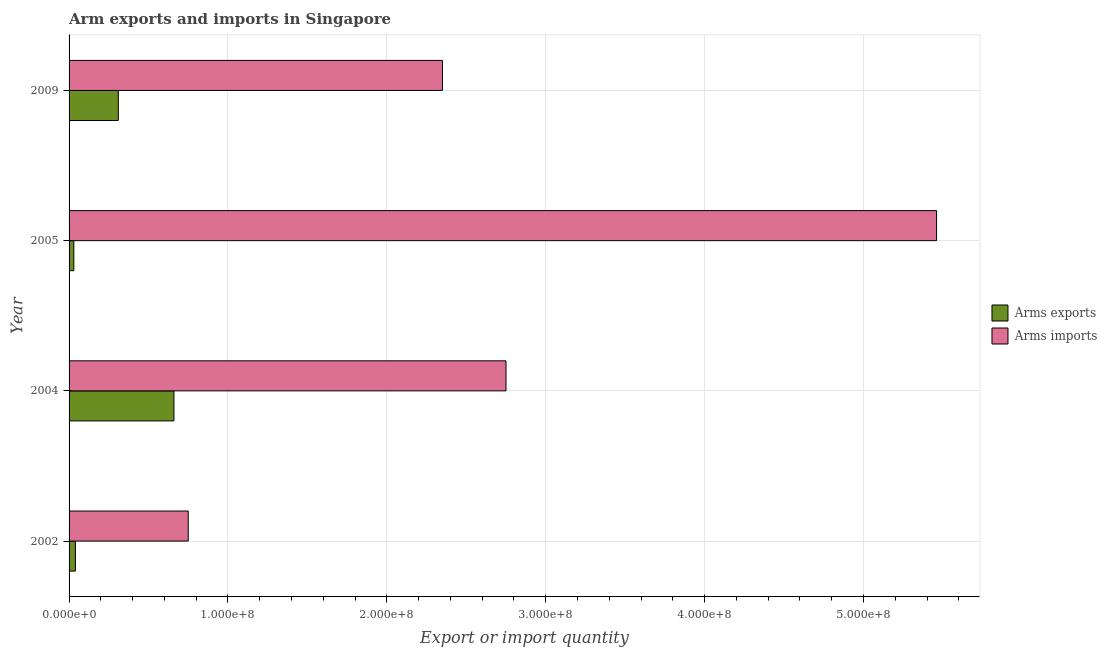Are the number of bars per tick equal to the number of legend labels?
Your response must be concise. Yes. How many bars are there on the 4th tick from the bottom?
Give a very brief answer. 2. In how many cases, is the number of bars for a given year not equal to the number of legend labels?
Provide a succinct answer. 0. What is the arms imports in 2002?
Make the answer very short. 7.50e+07. Across all years, what is the maximum arms exports?
Provide a short and direct response. 6.60e+07. Across all years, what is the minimum arms exports?
Your response must be concise. 3.00e+06. In which year was the arms imports maximum?
Your answer should be compact. 2005. In which year was the arms exports minimum?
Ensure brevity in your answer.  2005. What is the total arms exports in the graph?
Make the answer very short. 1.04e+08. What is the difference between the arms exports in 2002 and that in 2005?
Make the answer very short. 1.00e+06. What is the difference between the arms imports in 2009 and the arms exports in 2005?
Make the answer very short. 2.32e+08. What is the average arms exports per year?
Offer a terse response. 2.60e+07. In the year 2009, what is the difference between the arms imports and arms exports?
Make the answer very short. 2.04e+08. What is the ratio of the arms exports in 2002 to that in 2004?
Offer a terse response. 0.06. Is the arms imports in 2002 less than that in 2004?
Your response must be concise. Yes. Is the difference between the arms imports in 2004 and 2005 greater than the difference between the arms exports in 2004 and 2005?
Ensure brevity in your answer.  No. What is the difference between the highest and the second highest arms imports?
Ensure brevity in your answer.  2.71e+08. What is the difference between the highest and the lowest arms exports?
Provide a succinct answer. 6.30e+07. In how many years, is the arms exports greater than the average arms exports taken over all years?
Keep it short and to the point. 2. What does the 1st bar from the top in 2005 represents?
Your response must be concise. Arms imports. What does the 1st bar from the bottom in 2004 represents?
Your answer should be compact. Arms exports. Are all the bars in the graph horizontal?
Give a very brief answer. Yes. How many years are there in the graph?
Offer a very short reply. 4. What is the difference between two consecutive major ticks on the X-axis?
Ensure brevity in your answer.  1.00e+08. Does the graph contain any zero values?
Make the answer very short. No. How many legend labels are there?
Ensure brevity in your answer.  2. What is the title of the graph?
Keep it short and to the point. Arm exports and imports in Singapore. Does "Mobile cellular" appear as one of the legend labels in the graph?
Offer a terse response. No. What is the label or title of the X-axis?
Offer a terse response. Export or import quantity. What is the Export or import quantity of Arms imports in 2002?
Offer a terse response. 7.50e+07. What is the Export or import quantity in Arms exports in 2004?
Provide a succinct answer. 6.60e+07. What is the Export or import quantity of Arms imports in 2004?
Give a very brief answer. 2.75e+08. What is the Export or import quantity in Arms exports in 2005?
Provide a short and direct response. 3.00e+06. What is the Export or import quantity of Arms imports in 2005?
Your answer should be very brief. 5.46e+08. What is the Export or import quantity of Arms exports in 2009?
Offer a terse response. 3.10e+07. What is the Export or import quantity in Arms imports in 2009?
Keep it short and to the point. 2.35e+08. Across all years, what is the maximum Export or import quantity in Arms exports?
Ensure brevity in your answer.  6.60e+07. Across all years, what is the maximum Export or import quantity in Arms imports?
Your response must be concise. 5.46e+08. Across all years, what is the minimum Export or import quantity of Arms exports?
Your answer should be very brief. 3.00e+06. Across all years, what is the minimum Export or import quantity in Arms imports?
Offer a terse response. 7.50e+07. What is the total Export or import quantity in Arms exports in the graph?
Your answer should be very brief. 1.04e+08. What is the total Export or import quantity of Arms imports in the graph?
Provide a succinct answer. 1.13e+09. What is the difference between the Export or import quantity of Arms exports in 2002 and that in 2004?
Your response must be concise. -6.20e+07. What is the difference between the Export or import quantity in Arms imports in 2002 and that in 2004?
Offer a terse response. -2.00e+08. What is the difference between the Export or import quantity of Arms imports in 2002 and that in 2005?
Keep it short and to the point. -4.71e+08. What is the difference between the Export or import quantity in Arms exports in 2002 and that in 2009?
Offer a terse response. -2.70e+07. What is the difference between the Export or import quantity in Arms imports in 2002 and that in 2009?
Give a very brief answer. -1.60e+08. What is the difference between the Export or import quantity of Arms exports in 2004 and that in 2005?
Ensure brevity in your answer.  6.30e+07. What is the difference between the Export or import quantity of Arms imports in 2004 and that in 2005?
Give a very brief answer. -2.71e+08. What is the difference between the Export or import quantity of Arms exports in 2004 and that in 2009?
Keep it short and to the point. 3.50e+07. What is the difference between the Export or import quantity in Arms imports in 2004 and that in 2009?
Your answer should be very brief. 4.00e+07. What is the difference between the Export or import quantity in Arms exports in 2005 and that in 2009?
Ensure brevity in your answer.  -2.80e+07. What is the difference between the Export or import quantity of Arms imports in 2005 and that in 2009?
Ensure brevity in your answer.  3.11e+08. What is the difference between the Export or import quantity in Arms exports in 2002 and the Export or import quantity in Arms imports in 2004?
Ensure brevity in your answer.  -2.71e+08. What is the difference between the Export or import quantity of Arms exports in 2002 and the Export or import quantity of Arms imports in 2005?
Offer a terse response. -5.42e+08. What is the difference between the Export or import quantity of Arms exports in 2002 and the Export or import quantity of Arms imports in 2009?
Provide a short and direct response. -2.31e+08. What is the difference between the Export or import quantity of Arms exports in 2004 and the Export or import quantity of Arms imports in 2005?
Keep it short and to the point. -4.80e+08. What is the difference between the Export or import quantity in Arms exports in 2004 and the Export or import quantity in Arms imports in 2009?
Provide a succinct answer. -1.69e+08. What is the difference between the Export or import quantity in Arms exports in 2005 and the Export or import quantity in Arms imports in 2009?
Give a very brief answer. -2.32e+08. What is the average Export or import quantity of Arms exports per year?
Your answer should be compact. 2.60e+07. What is the average Export or import quantity of Arms imports per year?
Ensure brevity in your answer.  2.83e+08. In the year 2002, what is the difference between the Export or import quantity of Arms exports and Export or import quantity of Arms imports?
Offer a terse response. -7.10e+07. In the year 2004, what is the difference between the Export or import quantity in Arms exports and Export or import quantity in Arms imports?
Ensure brevity in your answer.  -2.09e+08. In the year 2005, what is the difference between the Export or import quantity in Arms exports and Export or import quantity in Arms imports?
Keep it short and to the point. -5.43e+08. In the year 2009, what is the difference between the Export or import quantity of Arms exports and Export or import quantity of Arms imports?
Your answer should be very brief. -2.04e+08. What is the ratio of the Export or import quantity in Arms exports in 2002 to that in 2004?
Make the answer very short. 0.06. What is the ratio of the Export or import quantity in Arms imports in 2002 to that in 2004?
Give a very brief answer. 0.27. What is the ratio of the Export or import quantity of Arms exports in 2002 to that in 2005?
Make the answer very short. 1.33. What is the ratio of the Export or import quantity of Arms imports in 2002 to that in 2005?
Offer a terse response. 0.14. What is the ratio of the Export or import quantity in Arms exports in 2002 to that in 2009?
Your answer should be compact. 0.13. What is the ratio of the Export or import quantity of Arms imports in 2002 to that in 2009?
Keep it short and to the point. 0.32. What is the ratio of the Export or import quantity in Arms imports in 2004 to that in 2005?
Your response must be concise. 0.5. What is the ratio of the Export or import quantity of Arms exports in 2004 to that in 2009?
Offer a terse response. 2.13. What is the ratio of the Export or import quantity in Arms imports in 2004 to that in 2009?
Your answer should be compact. 1.17. What is the ratio of the Export or import quantity of Arms exports in 2005 to that in 2009?
Make the answer very short. 0.1. What is the ratio of the Export or import quantity of Arms imports in 2005 to that in 2009?
Keep it short and to the point. 2.32. What is the difference between the highest and the second highest Export or import quantity of Arms exports?
Your response must be concise. 3.50e+07. What is the difference between the highest and the second highest Export or import quantity of Arms imports?
Your answer should be compact. 2.71e+08. What is the difference between the highest and the lowest Export or import quantity of Arms exports?
Provide a short and direct response. 6.30e+07. What is the difference between the highest and the lowest Export or import quantity in Arms imports?
Offer a terse response. 4.71e+08. 